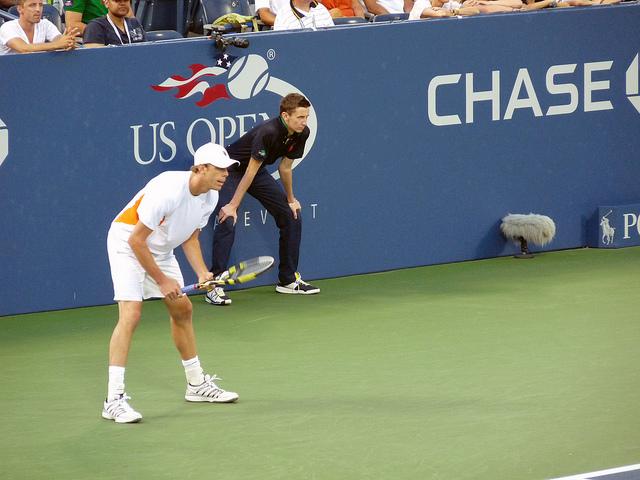What sport are they playing?
Give a very brief answer. Tennis. What bank is sponsoring the event?
Write a very short answer. Chase. Is his back going to hurt later?
Concise answer only. No. 